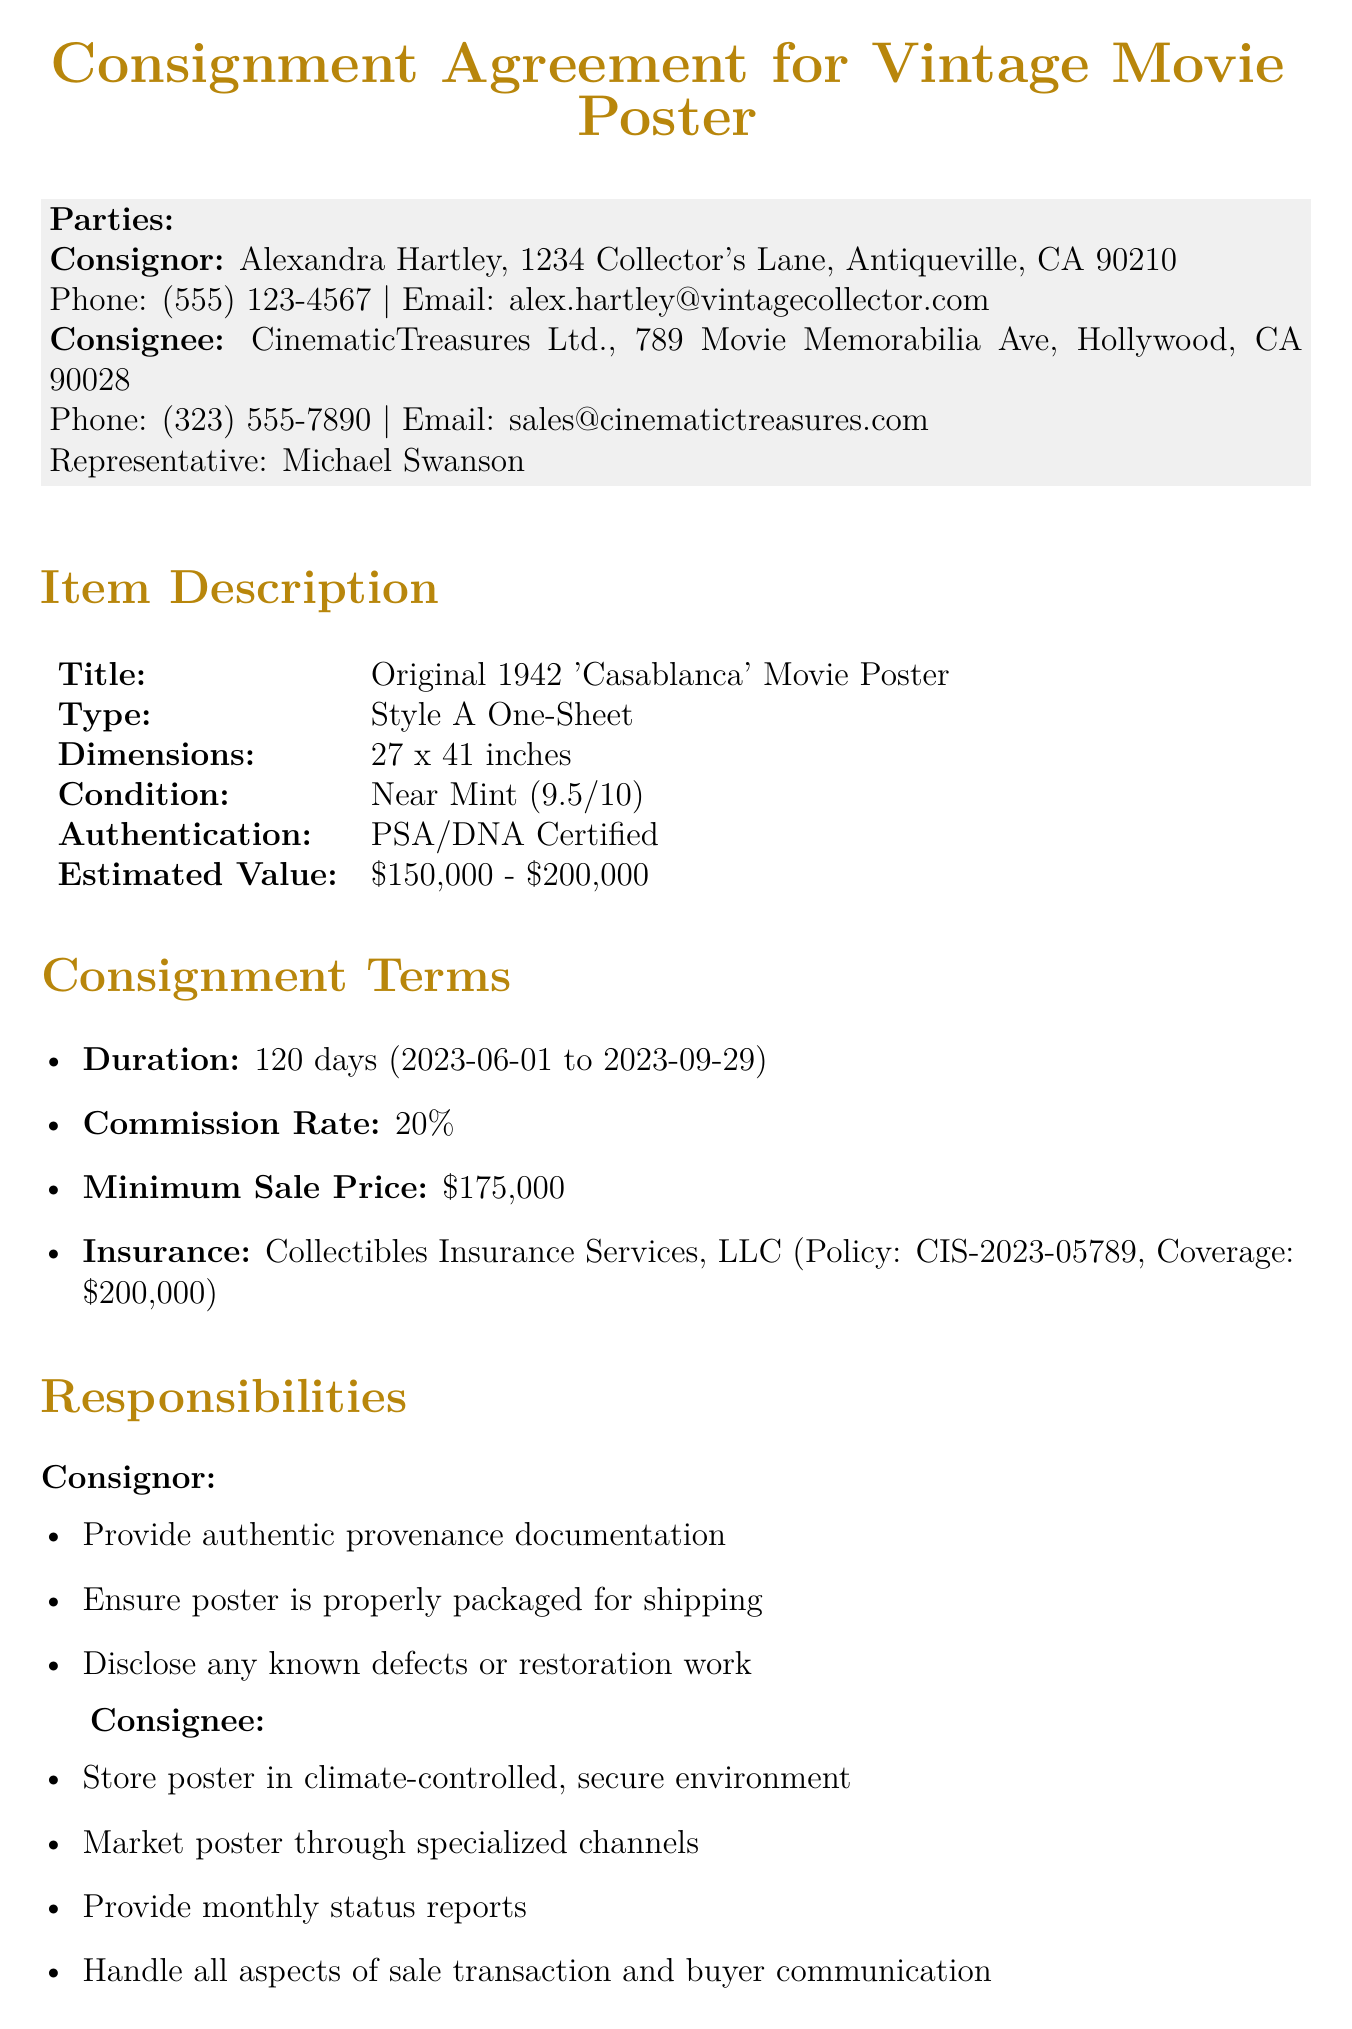What is the name of the consignor? The consignor's name is stated in the document as Alexandra Hartley.
Answer: Alexandra Hartley What is the phone number of the consignee? The consignee's phone number is listed in the document, providing a direct contact number.
Answer: (323) 555-7890 What is the estimated value of the movie poster? The estimated value range for the movie poster is specified in the document.
Answer: $150,000 - $200,000 What is the commission rate for the consignee? The document details the commission percentage that the consignee will take from the sale.
Answer: 20% How many days is the consignment duration? The document specifies the total duration in days for which the consignment agreement is valid.
Answer: 120 days What is the minimum sale price outlined in the agreement? The minimum sale price is a critical aspect of the consignment terms mentioned in the document.
Answer: $175,000 What must the consignee provide monthly? The document outlines specific responsibilities of the consignee, including timely updates.
Answer: Status reports What happens if the consignor wants to terminate the agreement? The document describes the procedure for termination initiated by the consignor and includes potential fees.
Answer: 30 days written notice Where will disputes be resolved? The document indicates the method and location for resolving any disputes arising from the agreement.
Answer: Los Angeles, California 